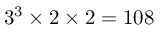Convert formula to latex. <formula><loc_0><loc_0><loc_500><loc_500>3 ^ { 3 } \times 2 \times 2 = 1 0 8</formula> 